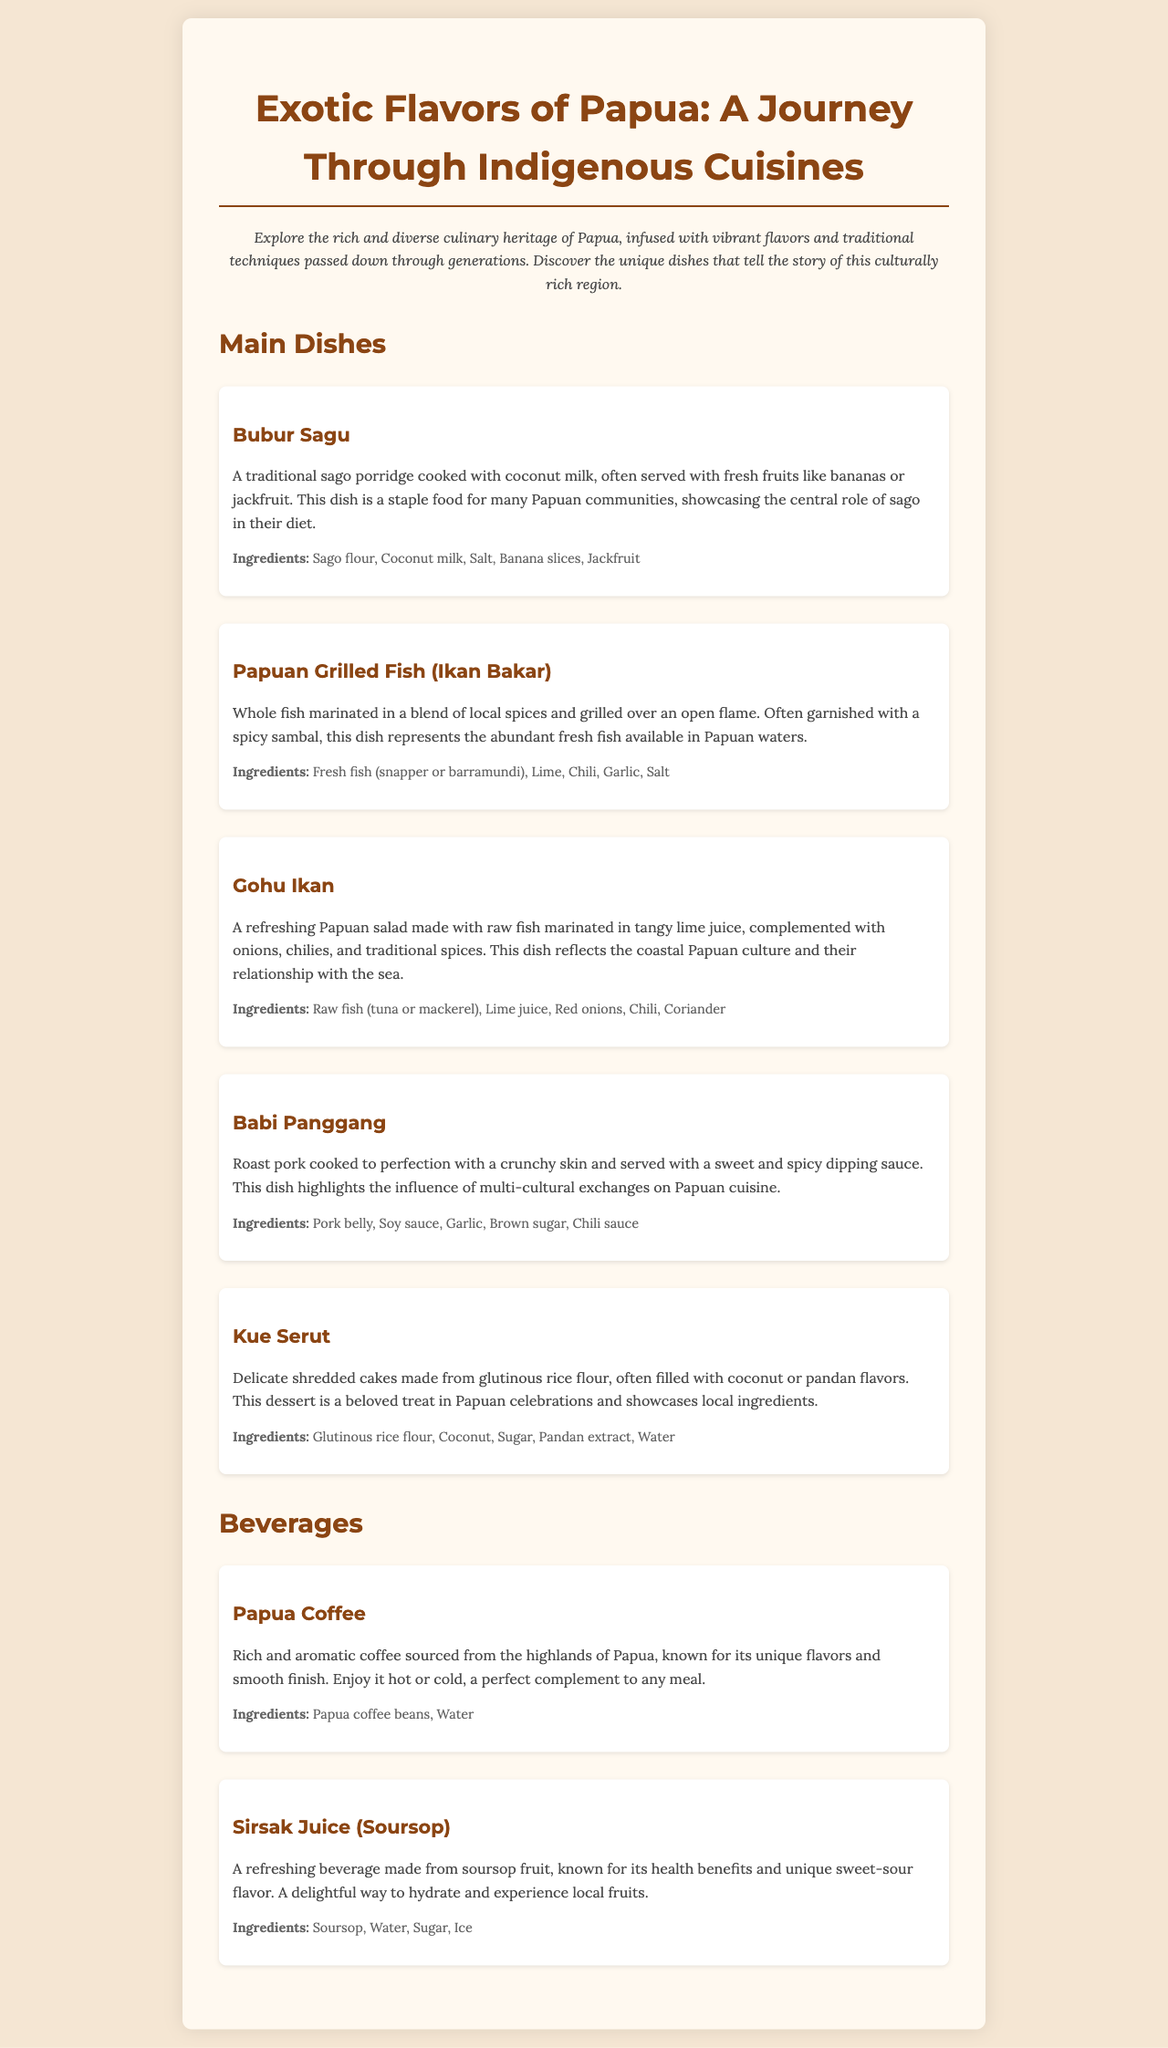What is the title of the menu? The title of the menu is prominently displayed at the top of the document, indicating the focus on Papuan cuisine.
Answer: Exotic Flavors of Papua: A Journey Through Indigenous Cuisines How many main dishes are listed? The number of main dishes can be counted under the "Main Dishes" section in the document.
Answer: Five What is the main ingredient of Bubur Sagu? The main ingredient for this dish is mentioned in the description, highlighting its importance in Papuan cuisine.
Answer: Sago flour Which beverage uses soursop? The beverage section includes a drink specifically made from the described fruit, indicating its unique flavor.
Answer: Sirsak Juice What type of fish is used in Gohu Ikan? The type of fish is specified in the ingredients, focusing on local seafood common in Papuan dishes.
Answer: Raw fish (tuna or mackerel) What cooking method is used for Papuan Grilled Fish? The cooking method is described in the preparation details of the dish, showcasing traditional techniques.
Answer: Grilled What is the flavor of Kue Serut? The flavor profile is characterized in the dish description, reflecting local culinary traditions.
Answer: Coconut or pandan flavors What are the two main ingredients in Papua Coffee? The beverage description lists the two essential components needed for this drink, illustrating its simplicity.
Answer: Papua coffee beans, Water How is Babi Panggang served? The serving style is mentioned in the description, highlighting its cultural significance in Papuan celebrations.
Answer: With a sweet and spicy dipping sauce 